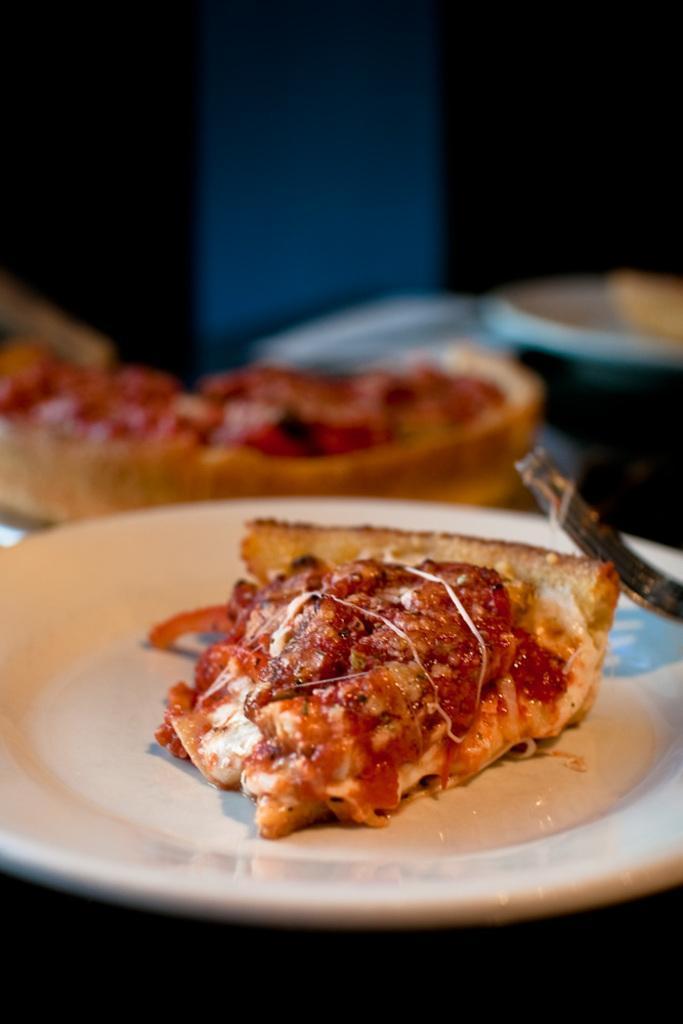In one or two sentences, can you explain what this image depicts? In the center of the image a food and a fork are present in the plate. 